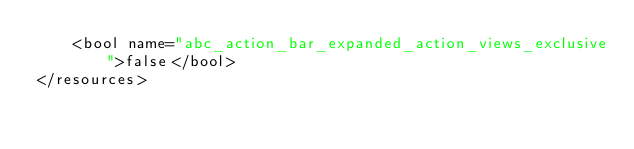Convert code to text. <code><loc_0><loc_0><loc_500><loc_500><_XML_>    <bool name="abc_action_bar_expanded_action_views_exclusive">false</bool>
</resources></code> 